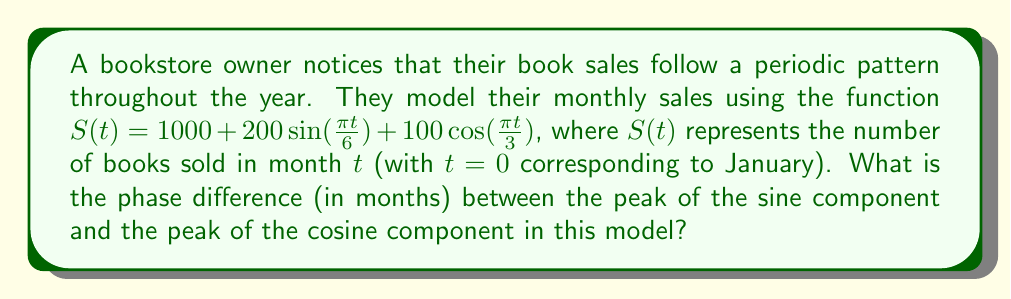Can you solve this math problem? To find the phase difference between the sine and cosine components, we need to follow these steps:

1) First, let's identify the general forms of the sine and cosine terms:
   $200\sin(\frac{\pi t}{6})$ and $100\cos(\frac{\pi t}{3})$

2) The period of a sine or cosine function is given by $\frac{2\pi}{\omega}$, where $\omega$ is the angular frequency.

3) For the sine term:
   $\omega_1 = \frac{\pi}{6}$
   Period = $\frac{2\pi}{\frac{\pi}{6}} = 12$ months

4) For the cosine term:
   $\omega_2 = \frac{\pi}{3}$
   Period = $\frac{2\pi}{\frac{\pi}{3}} = 6$ months

5) The sine function peaks at $t = \frac{\pi}{2}$, while cosine peaks at $t = 0$.

6) For the sine term to peak:
   $\frac{\pi t}{6} = \frac{\pi}{2}$
   $t = 3$ months

7) The cosine term already peaks at $t = 0$.

8) The phase difference is thus 3 months.
Answer: 3 months 